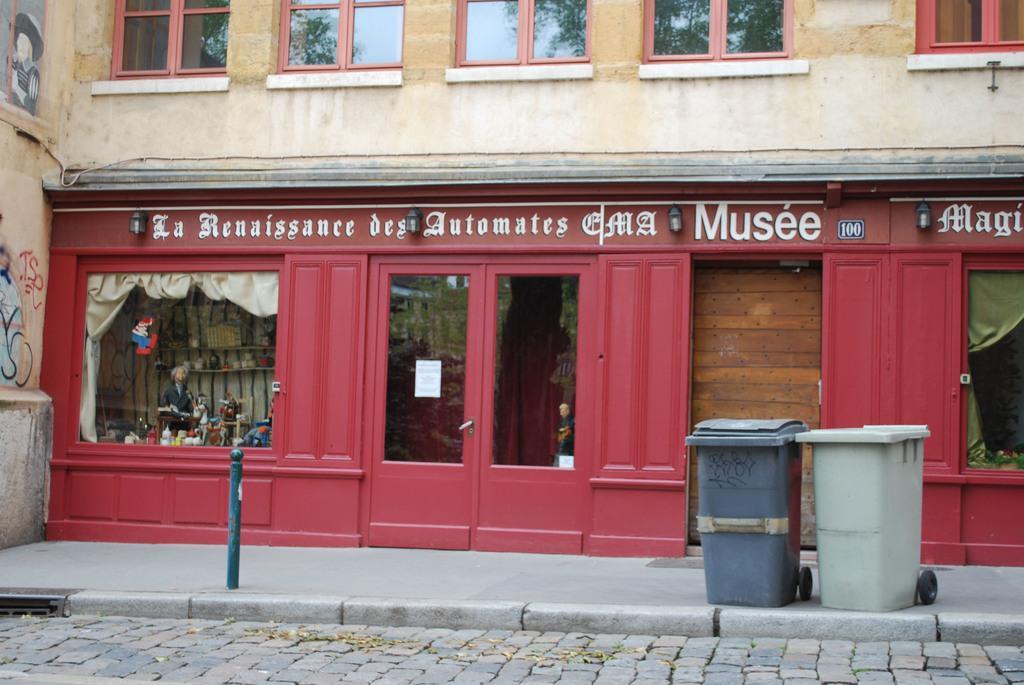How would you summarize this image in a sentence or two? In this image, we can see the wall with some glass windows and doors. We can also see a store. We can see some cloth and some shelves with objects. We can also see some text. We can see a pole and the ground with some objects. 